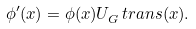Convert formula to latex. <formula><loc_0><loc_0><loc_500><loc_500>\phi ^ { \prime } ( x ) = \phi ( x ) U _ { G } ^ { \ } t r a n s ( x ) .</formula> 